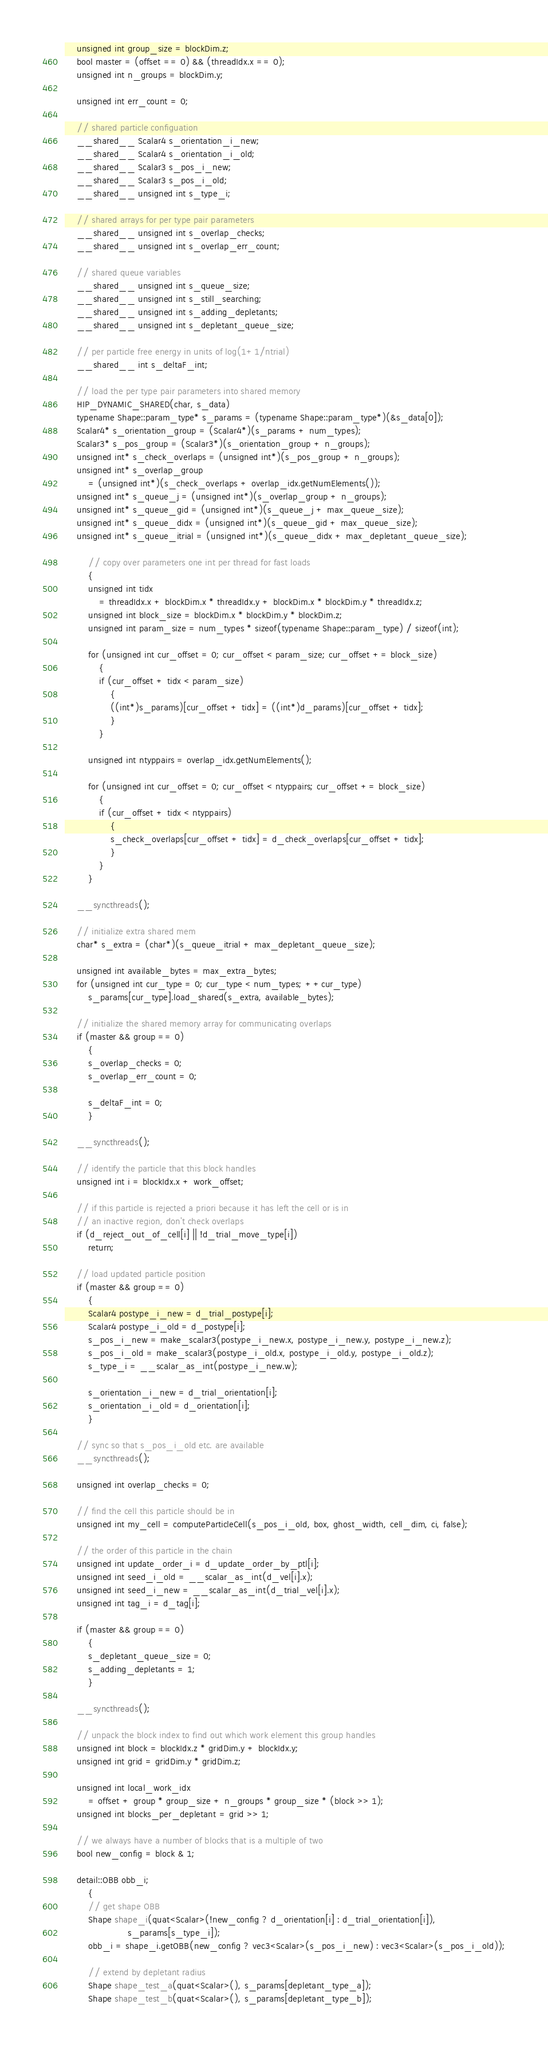Convert code to text. <code><loc_0><loc_0><loc_500><loc_500><_Cuda_>    unsigned int group_size = blockDim.z;
    bool master = (offset == 0) && (threadIdx.x == 0);
    unsigned int n_groups = blockDim.y;

    unsigned int err_count = 0;

    // shared particle configuation
    __shared__ Scalar4 s_orientation_i_new;
    __shared__ Scalar4 s_orientation_i_old;
    __shared__ Scalar3 s_pos_i_new;
    __shared__ Scalar3 s_pos_i_old;
    __shared__ unsigned int s_type_i;

    // shared arrays for per type pair parameters
    __shared__ unsigned int s_overlap_checks;
    __shared__ unsigned int s_overlap_err_count;

    // shared queue variables
    __shared__ unsigned int s_queue_size;
    __shared__ unsigned int s_still_searching;
    __shared__ unsigned int s_adding_depletants;
    __shared__ unsigned int s_depletant_queue_size;

    // per particle free energy in units of log(1+1/ntrial)
    __shared__ int s_deltaF_int;

    // load the per type pair parameters into shared memory
    HIP_DYNAMIC_SHARED(char, s_data)
    typename Shape::param_type* s_params = (typename Shape::param_type*)(&s_data[0]);
    Scalar4* s_orientation_group = (Scalar4*)(s_params + num_types);
    Scalar3* s_pos_group = (Scalar3*)(s_orientation_group + n_groups);
    unsigned int* s_check_overlaps = (unsigned int*)(s_pos_group + n_groups);
    unsigned int* s_overlap_group
        = (unsigned int*)(s_check_overlaps + overlap_idx.getNumElements());
    unsigned int* s_queue_j = (unsigned int*)(s_overlap_group + n_groups);
    unsigned int* s_queue_gid = (unsigned int*)(s_queue_j + max_queue_size);
    unsigned int* s_queue_didx = (unsigned int*)(s_queue_gid + max_queue_size);
    unsigned int* s_queue_itrial = (unsigned int*)(s_queue_didx + max_depletant_queue_size);

        // copy over parameters one int per thread for fast loads
        {
        unsigned int tidx
            = threadIdx.x + blockDim.x * threadIdx.y + blockDim.x * blockDim.y * threadIdx.z;
        unsigned int block_size = blockDim.x * blockDim.y * blockDim.z;
        unsigned int param_size = num_types * sizeof(typename Shape::param_type) / sizeof(int);

        for (unsigned int cur_offset = 0; cur_offset < param_size; cur_offset += block_size)
            {
            if (cur_offset + tidx < param_size)
                {
                ((int*)s_params)[cur_offset + tidx] = ((int*)d_params)[cur_offset + tidx];
                }
            }

        unsigned int ntyppairs = overlap_idx.getNumElements();

        for (unsigned int cur_offset = 0; cur_offset < ntyppairs; cur_offset += block_size)
            {
            if (cur_offset + tidx < ntyppairs)
                {
                s_check_overlaps[cur_offset + tidx] = d_check_overlaps[cur_offset + tidx];
                }
            }
        }

    __syncthreads();

    // initialize extra shared mem
    char* s_extra = (char*)(s_queue_itrial + max_depletant_queue_size);

    unsigned int available_bytes = max_extra_bytes;
    for (unsigned int cur_type = 0; cur_type < num_types; ++cur_type)
        s_params[cur_type].load_shared(s_extra, available_bytes);

    // initialize the shared memory array for communicating overlaps
    if (master && group == 0)
        {
        s_overlap_checks = 0;
        s_overlap_err_count = 0;

        s_deltaF_int = 0;
        }

    __syncthreads();

    // identify the particle that this block handles
    unsigned int i = blockIdx.x + work_offset;

    // if this particle is rejected a priori because it has left the cell or is in
    // an inactive region, don't check overlaps
    if (d_reject_out_of_cell[i] || !d_trial_move_type[i])
        return;

    // load updated particle position
    if (master && group == 0)
        {
        Scalar4 postype_i_new = d_trial_postype[i];
        Scalar4 postype_i_old = d_postype[i];
        s_pos_i_new = make_scalar3(postype_i_new.x, postype_i_new.y, postype_i_new.z);
        s_pos_i_old = make_scalar3(postype_i_old.x, postype_i_old.y, postype_i_old.z);
        s_type_i = __scalar_as_int(postype_i_new.w);

        s_orientation_i_new = d_trial_orientation[i];
        s_orientation_i_old = d_orientation[i];
        }

    // sync so that s_pos_i_old etc. are available
    __syncthreads();

    unsigned int overlap_checks = 0;

    // find the cell this particle should be in
    unsigned int my_cell = computeParticleCell(s_pos_i_old, box, ghost_width, cell_dim, ci, false);

    // the order of this particle in the chain
    unsigned int update_order_i = d_update_order_by_ptl[i];
    unsigned int seed_i_old = __scalar_as_int(d_vel[i].x);
    unsigned int seed_i_new = __scalar_as_int(d_trial_vel[i].x);
    unsigned int tag_i = d_tag[i];

    if (master && group == 0)
        {
        s_depletant_queue_size = 0;
        s_adding_depletants = 1;
        }

    __syncthreads();

    // unpack the block index to find out which work element this group handles
    unsigned int block = blockIdx.z * gridDim.y + blockIdx.y;
    unsigned int grid = gridDim.y * gridDim.z;

    unsigned int local_work_idx
        = offset + group * group_size + n_groups * group_size * (block >> 1);
    unsigned int blocks_per_depletant = grid >> 1;

    // we always have a number of blocks that is a multiple of two
    bool new_config = block & 1;

    detail::OBB obb_i;
        {
        // get shape OBB
        Shape shape_i(quat<Scalar>(!new_config ? d_orientation[i] : d_trial_orientation[i]),
                      s_params[s_type_i]);
        obb_i = shape_i.getOBB(new_config ? vec3<Scalar>(s_pos_i_new) : vec3<Scalar>(s_pos_i_old));

        // extend by depletant radius
        Shape shape_test_a(quat<Scalar>(), s_params[depletant_type_a]);
        Shape shape_test_b(quat<Scalar>(), s_params[depletant_type_b]);
</code> 